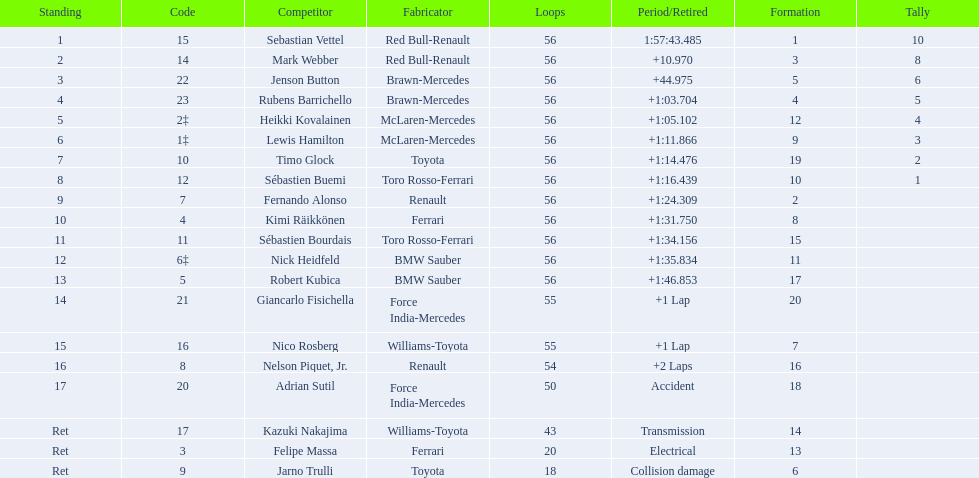Which drivers took part in the 2009 chinese grand prix? Sebastian Vettel, Mark Webber, Jenson Button, Rubens Barrichello, Heikki Kovalainen, Lewis Hamilton, Timo Glock, Sébastien Buemi, Fernando Alonso, Kimi Räikkönen, Sébastien Bourdais, Nick Heidfeld, Robert Kubica, Giancarlo Fisichella, Nico Rosberg, Nelson Piquet, Jr., Adrian Sutil, Kazuki Nakajima, Felipe Massa, Jarno Trulli. Of these, who completed all 56 laps? Sebastian Vettel, Mark Webber, Jenson Button, Rubens Barrichello, Heikki Kovalainen, Lewis Hamilton, Timo Glock, Sébastien Buemi, Fernando Alonso, Kimi Räikkönen, Sébastien Bourdais, Nick Heidfeld, Robert Kubica. Of these, which did ferrari not participate as a constructor? Sebastian Vettel, Mark Webber, Jenson Button, Rubens Barrichello, Heikki Kovalainen, Lewis Hamilton, Timo Glock, Fernando Alonso, Kimi Räikkönen, Nick Heidfeld, Robert Kubica. Of the remaining, which is in pos 1? Sebastian Vettel. 